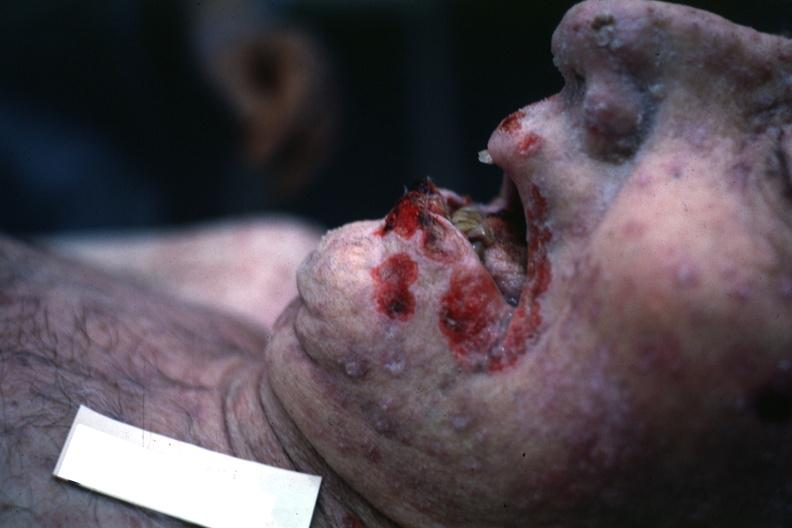what is present?
Answer the question using a single word or phrase. Lip 